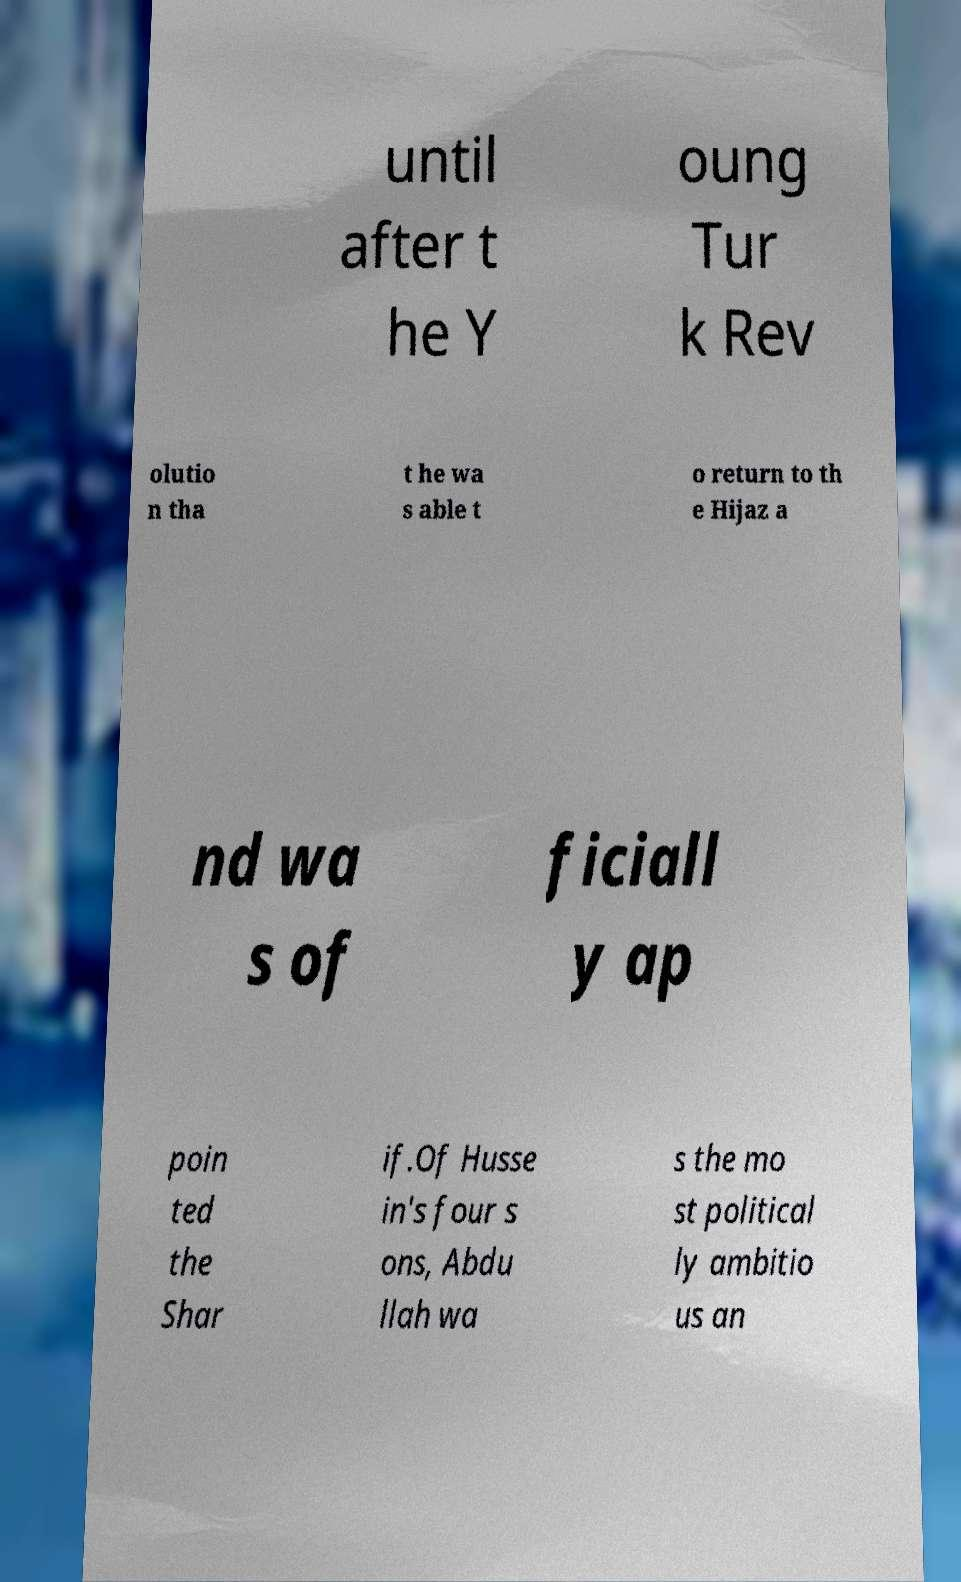I need the written content from this picture converted into text. Can you do that? until after t he Y oung Tur k Rev olutio n tha t he wa s able t o return to th e Hijaz a nd wa s of ficiall y ap poin ted the Shar if.Of Husse in's four s ons, Abdu llah wa s the mo st political ly ambitio us an 